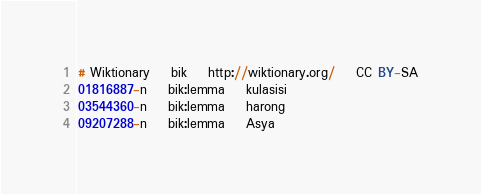<code> <loc_0><loc_0><loc_500><loc_500><_SQL_># Wiktionary	bik	http://wiktionary.org/	CC BY-SA
01816887-n	bik:lemma	kulasisi
03544360-n	bik:lemma	harong
09207288-n	bik:lemma	Asya
</code> 